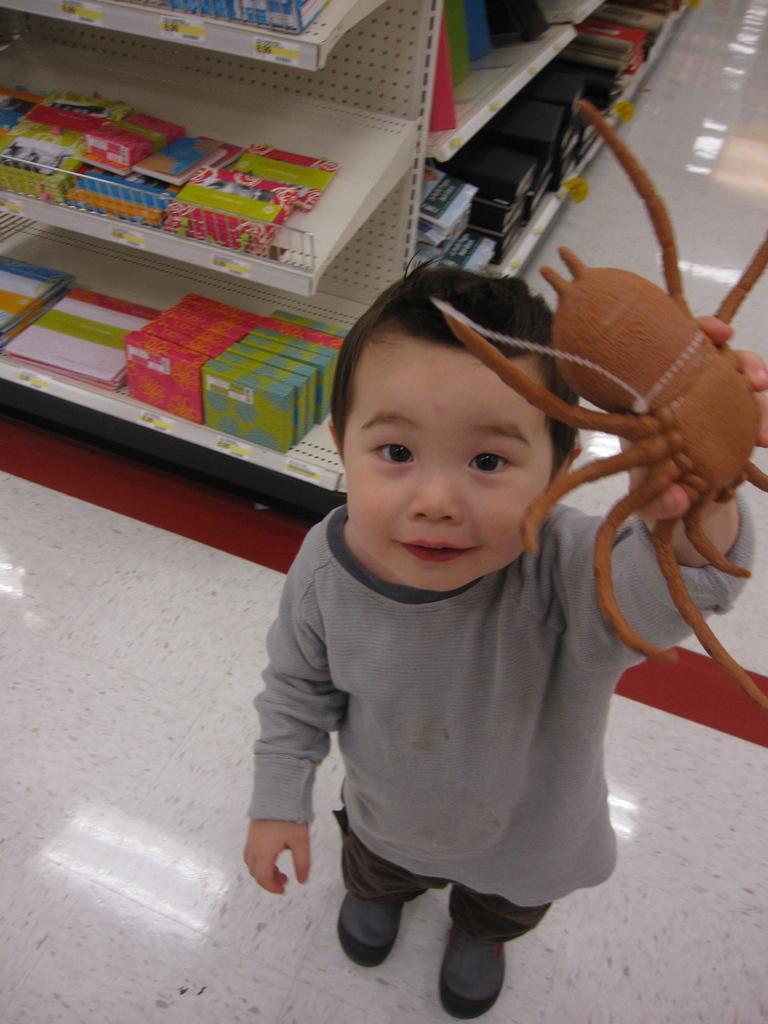How would you summarize this image in a sentence or two? There is a boy in gray color t-shirt holding a toy spider with one hand, smiling and standing on the white color floor. In the background, there are boxes, packets and other objects arranged on the shelves. 